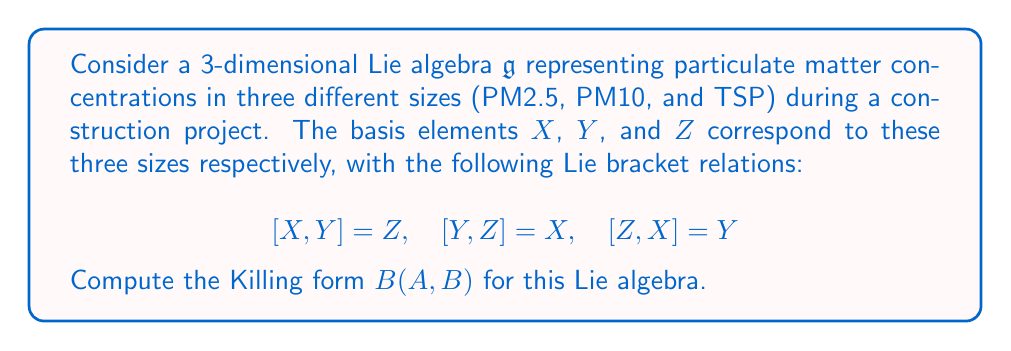Solve this math problem. To compute the Killing form for this Lie algebra, we need to follow these steps:

1) The Killing form is defined as $B(A,B) = \text{tr}(\text{ad}(A) \circ \text{ad}(B))$, where $\text{ad}$ is the adjoint representation and $\text{tr}$ is the trace.

2) First, we need to find the matrix representations of $\text{ad}(X)$, $\text{ad}(Y)$, and $\text{ad}(Z)$:

   For $\text{ad}(X)$:
   $$\text{ad}(X)(X) = 0$$
   $$\text{ad}(X)(Y) = [X,Y] = Z$$
   $$\text{ad}(X)(Z) = [X,Z] = -Y$$

   So, $\text{ad}(X) = \begin{pmatrix} 0 & 0 & 0 \\ 0 & 0 & -1 \\ 0 & 1 & 0 \end{pmatrix}$

   Similarly,
   $\text{ad}(Y) = \begin{pmatrix} 0 & 0 & 1 \\ 0 & 0 & 0 \\ -1 & 0 & 0 \end{pmatrix}$

   $\text{ad}(Z) = \begin{pmatrix} 0 & -1 & 0 \\ 1 & 0 & 0 \\ 0 & 0 & 0 \end{pmatrix}$

3) Now, we can compute $B(X,X)$, $B(Y,Y)$, $B(Z,Z)$, $B(X,Y)$, $B(Y,Z)$, and $B(X,Z)$:

   $B(X,X) = \text{tr}(\text{ad}(X) \circ \text{ad}(X)) = \text{tr}(\begin{pmatrix} 0 & 0 & 0 \\ 0 & -1 & 0 \\ 0 & 0 & -1 \end{pmatrix}) = -2$

   Similarly, $B(Y,Y) = B(Z,Z) = -2$

   $B(X,Y) = \text{tr}(\text{ad}(X) \circ \text{ad}(Y)) = \text{tr}(\begin{pmatrix} 0 & -1 & 0 \\ 0 & 0 & 0 \\ 1 & 0 & 0 \end{pmatrix}) = 0$

   Similarly, $B(Y,Z) = B(X,Z) = 0$

4) Therefore, the Killing form can be expressed as:

   $B(aX + bY + cZ, dX + eY + fZ) = -2(ad + be + cf)$

This Killing form represents how the concentrations of different particulate matter sizes interact and affect each other during the construction project.
Answer: The Killing form for the given Lie algebra is:

$$B(aX + bY + cZ, dX + eY + fZ) = -2(ad + be + cf)$$

where $a$, $b$, $c$, $d$, $e$, and $f$ are real numbers, and $X$, $Y$, and $Z$ are the basis elements representing PM2.5, PM10, and TSP concentrations respectively. 